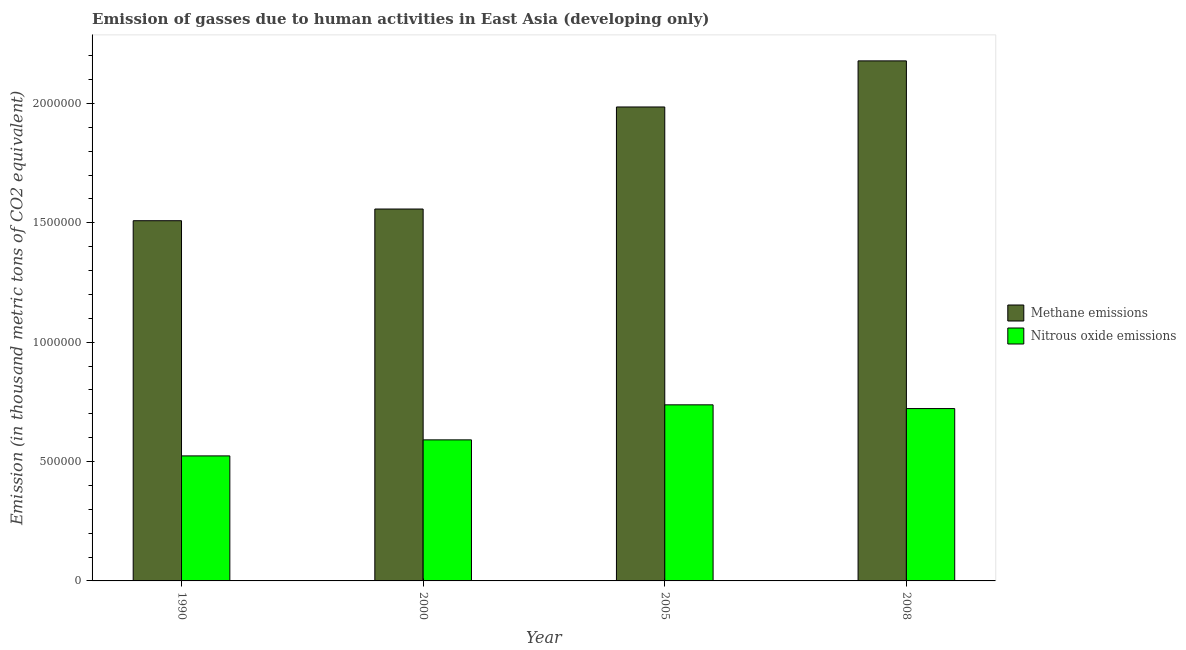How many different coloured bars are there?
Your answer should be compact. 2. How many bars are there on the 1st tick from the left?
Your response must be concise. 2. How many bars are there on the 3rd tick from the right?
Ensure brevity in your answer.  2. What is the label of the 3rd group of bars from the left?
Provide a succinct answer. 2005. In how many cases, is the number of bars for a given year not equal to the number of legend labels?
Offer a very short reply. 0. What is the amount of nitrous oxide emissions in 2000?
Offer a terse response. 5.91e+05. Across all years, what is the maximum amount of nitrous oxide emissions?
Give a very brief answer. 7.38e+05. Across all years, what is the minimum amount of methane emissions?
Make the answer very short. 1.51e+06. In which year was the amount of nitrous oxide emissions minimum?
Offer a very short reply. 1990. What is the total amount of methane emissions in the graph?
Keep it short and to the point. 7.23e+06. What is the difference between the amount of methane emissions in 2005 and that in 2008?
Your answer should be very brief. -1.93e+05. What is the difference between the amount of nitrous oxide emissions in 1990 and the amount of methane emissions in 2005?
Make the answer very short. -2.14e+05. What is the average amount of nitrous oxide emissions per year?
Offer a terse response. 6.43e+05. In how many years, is the amount of methane emissions greater than 2000000 thousand metric tons?
Your answer should be compact. 1. What is the ratio of the amount of methane emissions in 2000 to that in 2008?
Offer a very short reply. 0.72. Is the amount of methane emissions in 1990 less than that in 2005?
Keep it short and to the point. Yes. What is the difference between the highest and the second highest amount of nitrous oxide emissions?
Your answer should be very brief. 1.57e+04. What is the difference between the highest and the lowest amount of nitrous oxide emissions?
Keep it short and to the point. 2.14e+05. In how many years, is the amount of nitrous oxide emissions greater than the average amount of nitrous oxide emissions taken over all years?
Offer a terse response. 2. What does the 2nd bar from the left in 2005 represents?
Offer a terse response. Nitrous oxide emissions. What does the 1st bar from the right in 2005 represents?
Your answer should be very brief. Nitrous oxide emissions. How many bars are there?
Offer a very short reply. 8. What is the difference between two consecutive major ticks on the Y-axis?
Give a very brief answer. 5.00e+05. What is the title of the graph?
Make the answer very short. Emission of gasses due to human activities in East Asia (developing only). What is the label or title of the X-axis?
Your answer should be compact. Year. What is the label or title of the Y-axis?
Offer a very short reply. Emission (in thousand metric tons of CO2 equivalent). What is the Emission (in thousand metric tons of CO2 equivalent) in Methane emissions in 1990?
Offer a terse response. 1.51e+06. What is the Emission (in thousand metric tons of CO2 equivalent) of Nitrous oxide emissions in 1990?
Provide a short and direct response. 5.24e+05. What is the Emission (in thousand metric tons of CO2 equivalent) in Methane emissions in 2000?
Your response must be concise. 1.56e+06. What is the Emission (in thousand metric tons of CO2 equivalent) of Nitrous oxide emissions in 2000?
Ensure brevity in your answer.  5.91e+05. What is the Emission (in thousand metric tons of CO2 equivalent) in Methane emissions in 2005?
Give a very brief answer. 1.99e+06. What is the Emission (in thousand metric tons of CO2 equivalent) of Nitrous oxide emissions in 2005?
Give a very brief answer. 7.38e+05. What is the Emission (in thousand metric tons of CO2 equivalent) of Methane emissions in 2008?
Offer a terse response. 2.18e+06. What is the Emission (in thousand metric tons of CO2 equivalent) in Nitrous oxide emissions in 2008?
Your answer should be compact. 7.22e+05. Across all years, what is the maximum Emission (in thousand metric tons of CO2 equivalent) of Methane emissions?
Your answer should be very brief. 2.18e+06. Across all years, what is the maximum Emission (in thousand metric tons of CO2 equivalent) of Nitrous oxide emissions?
Your answer should be compact. 7.38e+05. Across all years, what is the minimum Emission (in thousand metric tons of CO2 equivalent) of Methane emissions?
Offer a very short reply. 1.51e+06. Across all years, what is the minimum Emission (in thousand metric tons of CO2 equivalent) of Nitrous oxide emissions?
Give a very brief answer. 5.24e+05. What is the total Emission (in thousand metric tons of CO2 equivalent) in Methane emissions in the graph?
Provide a succinct answer. 7.23e+06. What is the total Emission (in thousand metric tons of CO2 equivalent) in Nitrous oxide emissions in the graph?
Your answer should be compact. 2.57e+06. What is the difference between the Emission (in thousand metric tons of CO2 equivalent) of Methane emissions in 1990 and that in 2000?
Offer a terse response. -4.90e+04. What is the difference between the Emission (in thousand metric tons of CO2 equivalent) in Nitrous oxide emissions in 1990 and that in 2000?
Provide a succinct answer. -6.71e+04. What is the difference between the Emission (in thousand metric tons of CO2 equivalent) of Methane emissions in 1990 and that in 2005?
Ensure brevity in your answer.  -4.76e+05. What is the difference between the Emission (in thousand metric tons of CO2 equivalent) in Nitrous oxide emissions in 1990 and that in 2005?
Ensure brevity in your answer.  -2.14e+05. What is the difference between the Emission (in thousand metric tons of CO2 equivalent) in Methane emissions in 1990 and that in 2008?
Your answer should be very brief. -6.69e+05. What is the difference between the Emission (in thousand metric tons of CO2 equivalent) in Nitrous oxide emissions in 1990 and that in 2008?
Provide a short and direct response. -1.98e+05. What is the difference between the Emission (in thousand metric tons of CO2 equivalent) in Methane emissions in 2000 and that in 2005?
Provide a short and direct response. -4.27e+05. What is the difference between the Emission (in thousand metric tons of CO2 equivalent) in Nitrous oxide emissions in 2000 and that in 2005?
Your answer should be compact. -1.47e+05. What is the difference between the Emission (in thousand metric tons of CO2 equivalent) of Methane emissions in 2000 and that in 2008?
Your answer should be compact. -6.20e+05. What is the difference between the Emission (in thousand metric tons of CO2 equivalent) in Nitrous oxide emissions in 2000 and that in 2008?
Your answer should be very brief. -1.31e+05. What is the difference between the Emission (in thousand metric tons of CO2 equivalent) of Methane emissions in 2005 and that in 2008?
Keep it short and to the point. -1.93e+05. What is the difference between the Emission (in thousand metric tons of CO2 equivalent) in Nitrous oxide emissions in 2005 and that in 2008?
Provide a succinct answer. 1.57e+04. What is the difference between the Emission (in thousand metric tons of CO2 equivalent) of Methane emissions in 1990 and the Emission (in thousand metric tons of CO2 equivalent) of Nitrous oxide emissions in 2000?
Your answer should be compact. 9.18e+05. What is the difference between the Emission (in thousand metric tons of CO2 equivalent) of Methane emissions in 1990 and the Emission (in thousand metric tons of CO2 equivalent) of Nitrous oxide emissions in 2005?
Your answer should be very brief. 7.71e+05. What is the difference between the Emission (in thousand metric tons of CO2 equivalent) of Methane emissions in 1990 and the Emission (in thousand metric tons of CO2 equivalent) of Nitrous oxide emissions in 2008?
Ensure brevity in your answer.  7.87e+05. What is the difference between the Emission (in thousand metric tons of CO2 equivalent) of Methane emissions in 2000 and the Emission (in thousand metric tons of CO2 equivalent) of Nitrous oxide emissions in 2005?
Offer a terse response. 8.20e+05. What is the difference between the Emission (in thousand metric tons of CO2 equivalent) in Methane emissions in 2000 and the Emission (in thousand metric tons of CO2 equivalent) in Nitrous oxide emissions in 2008?
Provide a succinct answer. 8.36e+05. What is the difference between the Emission (in thousand metric tons of CO2 equivalent) in Methane emissions in 2005 and the Emission (in thousand metric tons of CO2 equivalent) in Nitrous oxide emissions in 2008?
Make the answer very short. 1.26e+06. What is the average Emission (in thousand metric tons of CO2 equivalent) of Methane emissions per year?
Offer a terse response. 1.81e+06. What is the average Emission (in thousand metric tons of CO2 equivalent) of Nitrous oxide emissions per year?
Give a very brief answer. 6.43e+05. In the year 1990, what is the difference between the Emission (in thousand metric tons of CO2 equivalent) in Methane emissions and Emission (in thousand metric tons of CO2 equivalent) in Nitrous oxide emissions?
Provide a short and direct response. 9.85e+05. In the year 2000, what is the difference between the Emission (in thousand metric tons of CO2 equivalent) of Methane emissions and Emission (in thousand metric tons of CO2 equivalent) of Nitrous oxide emissions?
Give a very brief answer. 9.67e+05. In the year 2005, what is the difference between the Emission (in thousand metric tons of CO2 equivalent) of Methane emissions and Emission (in thousand metric tons of CO2 equivalent) of Nitrous oxide emissions?
Provide a short and direct response. 1.25e+06. In the year 2008, what is the difference between the Emission (in thousand metric tons of CO2 equivalent) in Methane emissions and Emission (in thousand metric tons of CO2 equivalent) in Nitrous oxide emissions?
Make the answer very short. 1.46e+06. What is the ratio of the Emission (in thousand metric tons of CO2 equivalent) in Methane emissions in 1990 to that in 2000?
Your response must be concise. 0.97. What is the ratio of the Emission (in thousand metric tons of CO2 equivalent) of Nitrous oxide emissions in 1990 to that in 2000?
Offer a very short reply. 0.89. What is the ratio of the Emission (in thousand metric tons of CO2 equivalent) in Methane emissions in 1990 to that in 2005?
Your answer should be compact. 0.76. What is the ratio of the Emission (in thousand metric tons of CO2 equivalent) in Nitrous oxide emissions in 1990 to that in 2005?
Your response must be concise. 0.71. What is the ratio of the Emission (in thousand metric tons of CO2 equivalent) in Methane emissions in 1990 to that in 2008?
Provide a short and direct response. 0.69. What is the ratio of the Emission (in thousand metric tons of CO2 equivalent) in Nitrous oxide emissions in 1990 to that in 2008?
Offer a terse response. 0.73. What is the ratio of the Emission (in thousand metric tons of CO2 equivalent) in Methane emissions in 2000 to that in 2005?
Give a very brief answer. 0.78. What is the ratio of the Emission (in thousand metric tons of CO2 equivalent) in Nitrous oxide emissions in 2000 to that in 2005?
Offer a very short reply. 0.8. What is the ratio of the Emission (in thousand metric tons of CO2 equivalent) of Methane emissions in 2000 to that in 2008?
Offer a very short reply. 0.72. What is the ratio of the Emission (in thousand metric tons of CO2 equivalent) of Nitrous oxide emissions in 2000 to that in 2008?
Your answer should be compact. 0.82. What is the ratio of the Emission (in thousand metric tons of CO2 equivalent) in Methane emissions in 2005 to that in 2008?
Give a very brief answer. 0.91. What is the ratio of the Emission (in thousand metric tons of CO2 equivalent) of Nitrous oxide emissions in 2005 to that in 2008?
Offer a very short reply. 1.02. What is the difference between the highest and the second highest Emission (in thousand metric tons of CO2 equivalent) of Methane emissions?
Your response must be concise. 1.93e+05. What is the difference between the highest and the second highest Emission (in thousand metric tons of CO2 equivalent) in Nitrous oxide emissions?
Make the answer very short. 1.57e+04. What is the difference between the highest and the lowest Emission (in thousand metric tons of CO2 equivalent) in Methane emissions?
Offer a terse response. 6.69e+05. What is the difference between the highest and the lowest Emission (in thousand metric tons of CO2 equivalent) in Nitrous oxide emissions?
Your answer should be very brief. 2.14e+05. 